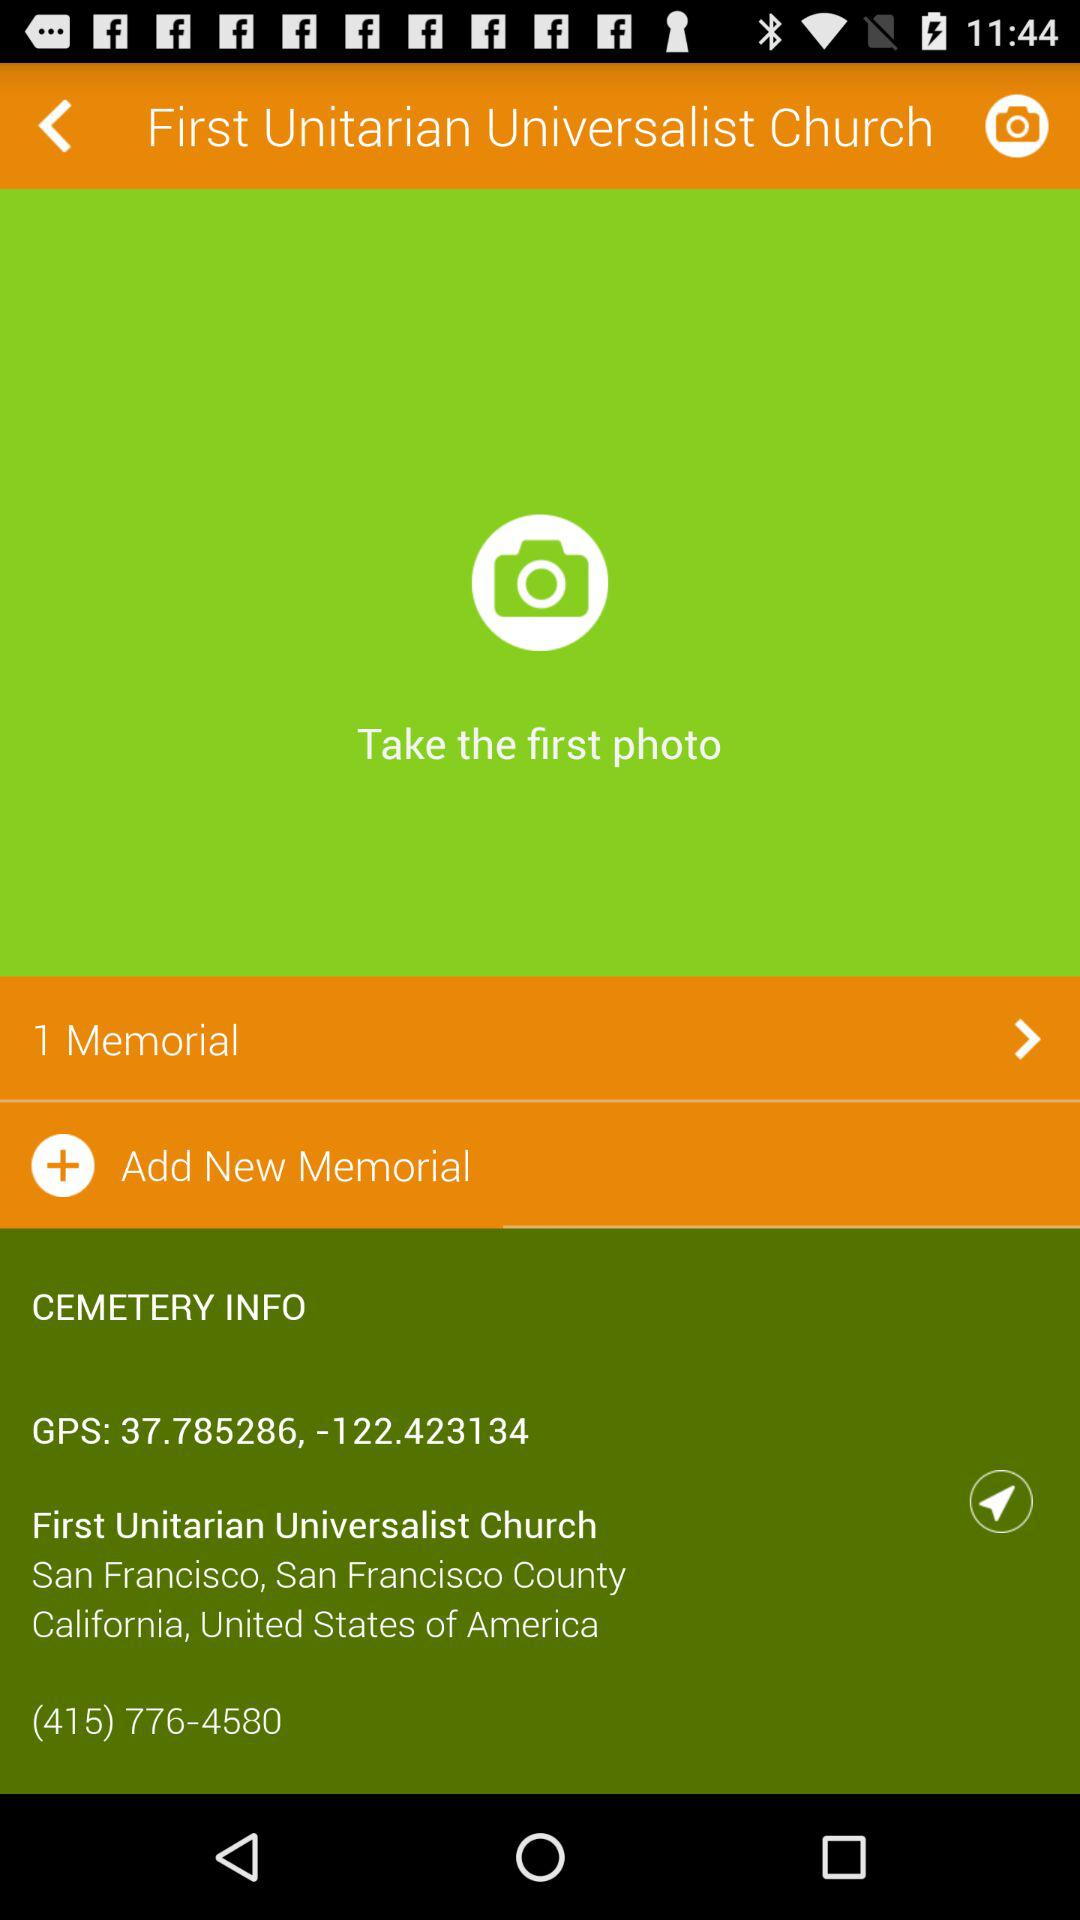What is the number of "Memorial" shown? The number of "Memorial" is 1. 